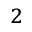Convert formula to latex. <formula><loc_0><loc_0><loc_500><loc_500>_ { 2 }</formula> 